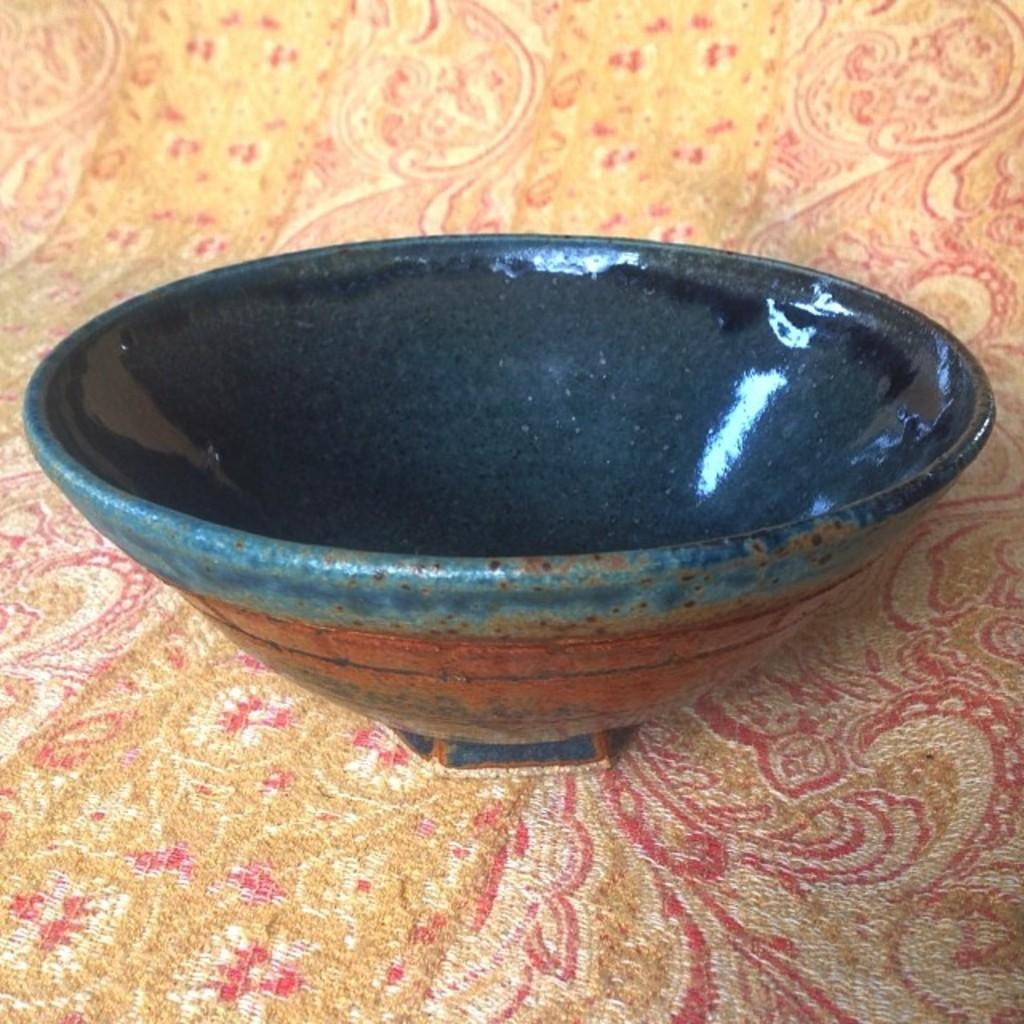What type of bowl is present in the image? There is a ceramic bowl in the image. Can you describe the material of the bowl? The bowl is made of ceramic. What might the bowl be used for? The bowl could be used for serving food or holding various items. What organization is responsible for the laborer working in the background of the image? There is no laborer or background present in the image; it only features a ceramic bowl. 